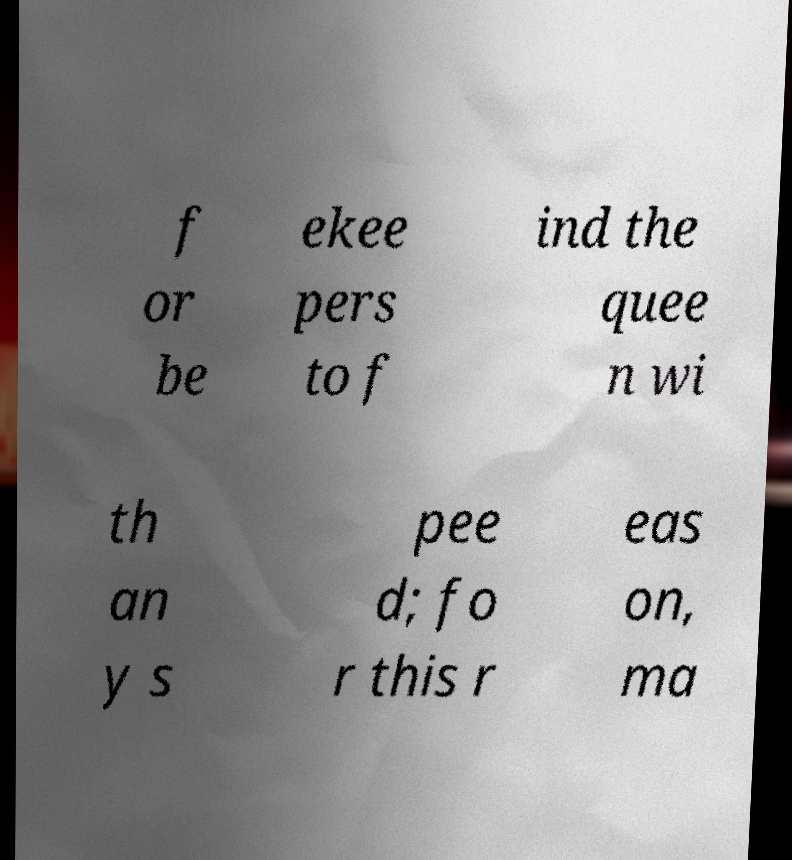There's text embedded in this image that I need extracted. Can you transcribe it verbatim? f or be ekee pers to f ind the quee n wi th an y s pee d; fo r this r eas on, ma 